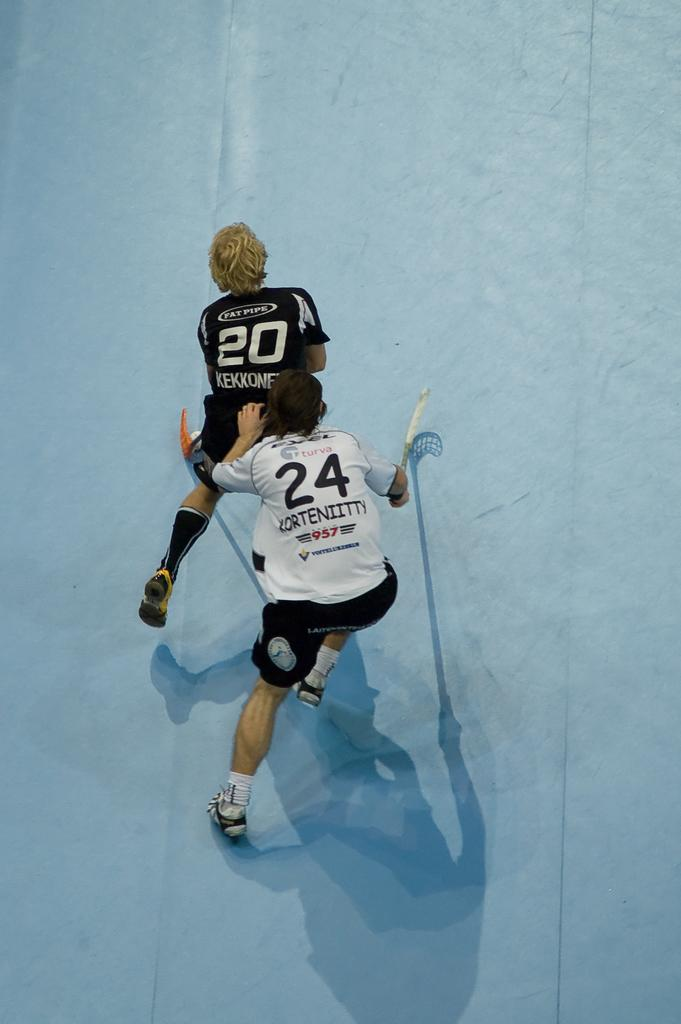<image>
Write a terse but informative summary of the picture. Player number 24 has his hand on the back of player number 20. 